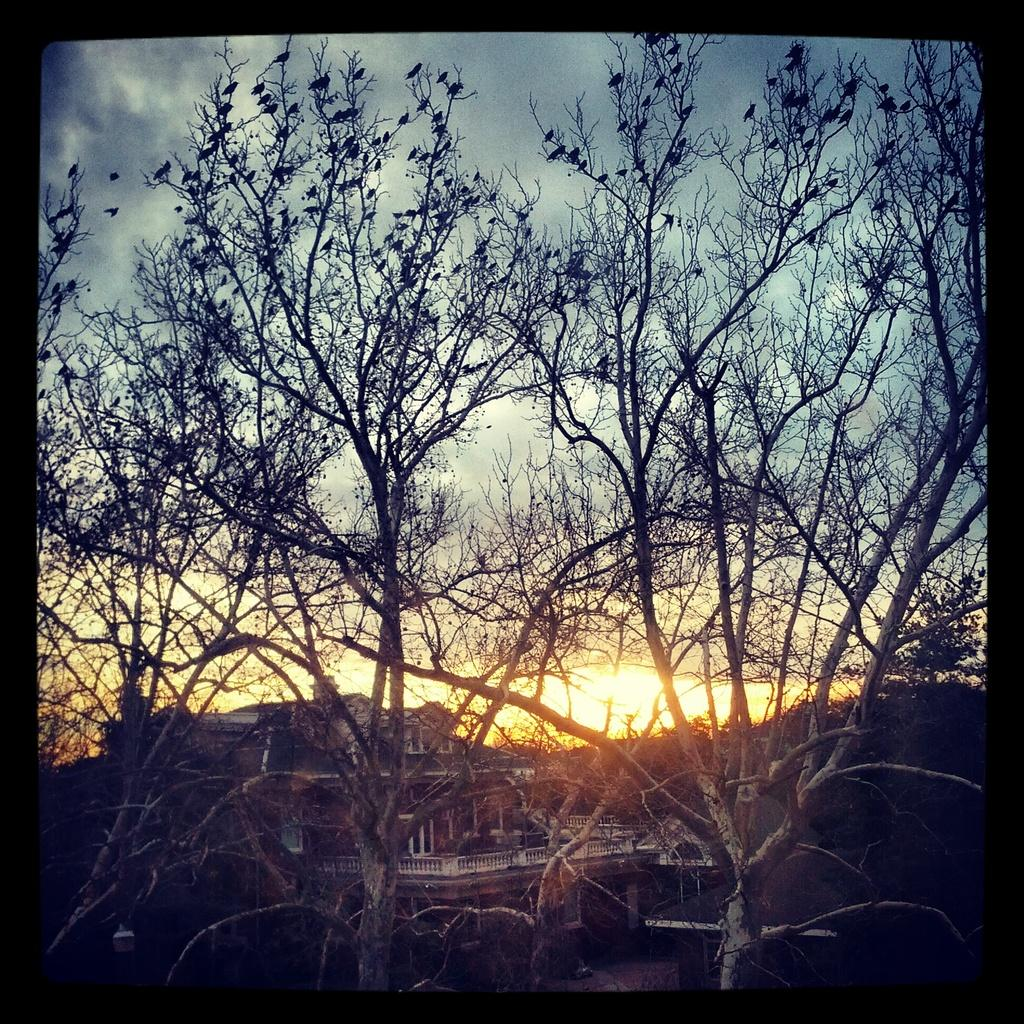What type of natural elements can be seen in the image? There are trees in the image. What type of man-made structures are visible in the background? There are buildings in the background of the image. What celestial body is visible in the sky? The sun is visible in the sky. What atmospheric conditions are present in the sky? Clouds are present in the sky. What type of guitar is being played at the meeting in the image? There is no guitar or meeting present in the image. How many icicles can be seen hanging from the trees in the image? A: There are no icicles present in the image; it is not a winter scene. 